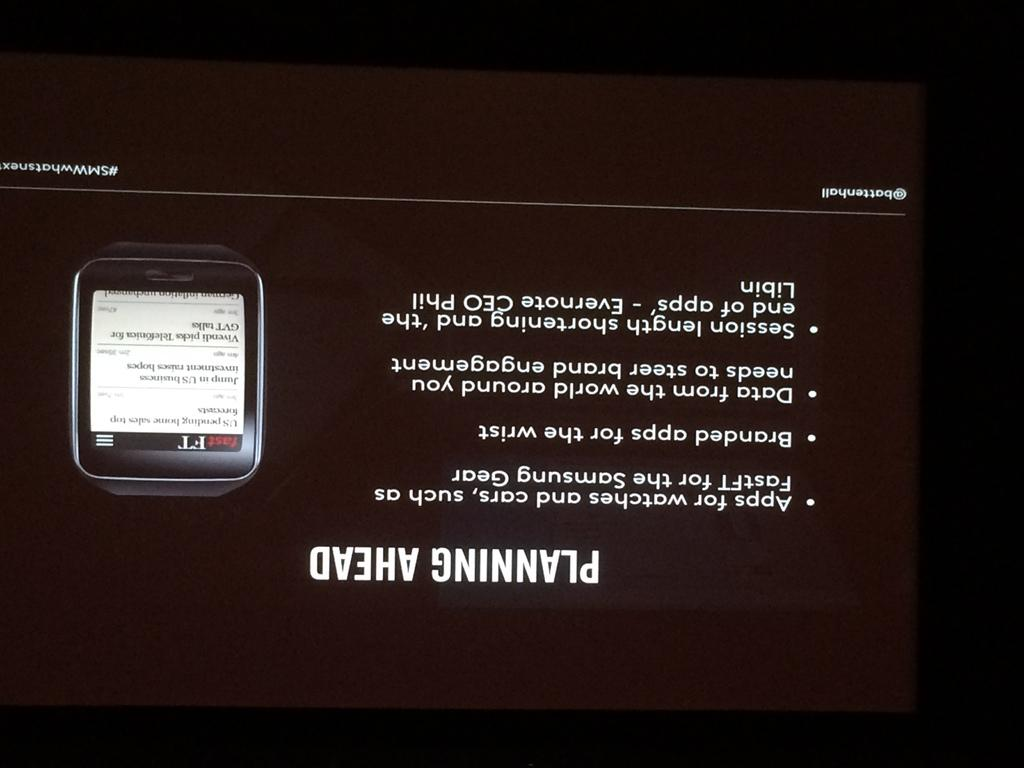<image>
Write a terse but informative summary of the picture. Planning Ahead device that has apps and data that is stored. 